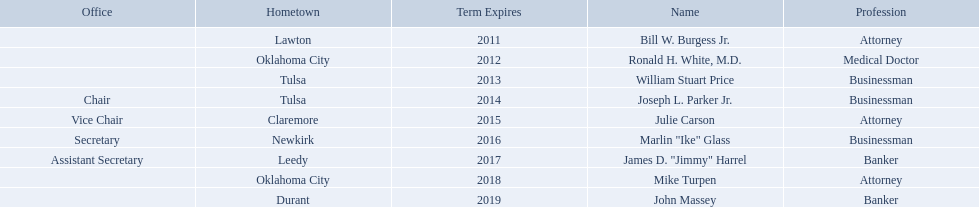Who are the state regents? Bill W. Burgess Jr., Ronald H. White, M.D., William Stuart Price, Joseph L. Parker Jr., Julie Carson, Marlin "Ike" Glass, James D. "Jimmy" Harrel, Mike Turpen, John Massey. Of those state regents, who is from the same hometown as ronald h. white, m.d.? Mike Turpen. 